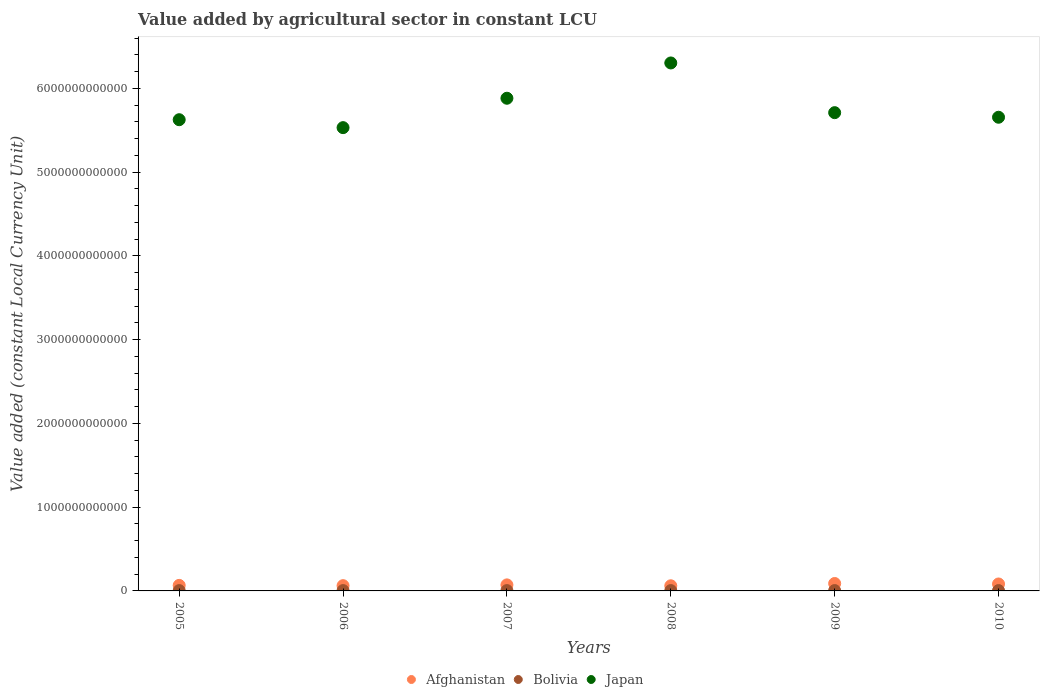How many different coloured dotlines are there?
Provide a succinct answer. 3. Is the number of dotlines equal to the number of legend labels?
Provide a short and direct response. Yes. What is the value added by agricultural sector in Afghanistan in 2006?
Give a very brief answer. 6.28e+1. Across all years, what is the maximum value added by agricultural sector in Bolivia?
Make the answer very short. 4.17e+09. Across all years, what is the minimum value added by agricultural sector in Afghanistan?
Ensure brevity in your answer.  6.13e+1. In which year was the value added by agricultural sector in Bolivia maximum?
Keep it short and to the point. 2009. In which year was the value added by agricultural sector in Bolivia minimum?
Ensure brevity in your answer.  2005. What is the total value added by agricultural sector in Afghanistan in the graph?
Ensure brevity in your answer.  4.34e+11. What is the difference between the value added by agricultural sector in Bolivia in 2008 and that in 2010?
Your response must be concise. -9.90e+07. What is the difference between the value added by agricultural sector in Bolivia in 2008 and the value added by agricultural sector in Japan in 2007?
Give a very brief answer. -5.88e+12. What is the average value added by agricultural sector in Afghanistan per year?
Your answer should be compact. 7.23e+1. In the year 2009, what is the difference between the value added by agricultural sector in Bolivia and value added by agricultural sector in Japan?
Provide a succinct answer. -5.71e+12. What is the ratio of the value added by agricultural sector in Afghanistan in 2007 to that in 2010?
Ensure brevity in your answer.  0.87. Is the difference between the value added by agricultural sector in Bolivia in 2006 and 2010 greater than the difference between the value added by agricultural sector in Japan in 2006 and 2010?
Ensure brevity in your answer.  Yes. What is the difference between the highest and the second highest value added by agricultural sector in Bolivia?
Ensure brevity in your answer.  4.91e+07. What is the difference between the highest and the lowest value added by agricultural sector in Japan?
Offer a very short reply. 7.72e+11. In how many years, is the value added by agricultural sector in Bolivia greater than the average value added by agricultural sector in Bolivia taken over all years?
Your answer should be very brief. 3. Is it the case that in every year, the sum of the value added by agricultural sector in Bolivia and value added by agricultural sector in Afghanistan  is greater than the value added by agricultural sector in Japan?
Offer a very short reply. No. What is the difference between two consecutive major ticks on the Y-axis?
Offer a very short reply. 1.00e+12. Are the values on the major ticks of Y-axis written in scientific E-notation?
Give a very brief answer. No. Does the graph contain grids?
Your answer should be very brief. No. What is the title of the graph?
Provide a short and direct response. Value added by agricultural sector in constant LCU. Does "Arab World" appear as one of the legend labels in the graph?
Provide a succinct answer. No. What is the label or title of the X-axis?
Offer a terse response. Years. What is the label or title of the Y-axis?
Ensure brevity in your answer.  Value added (constant Local Currency Unit). What is the Value added (constant Local Currency Unit) in Afghanistan in 2005?
Provide a short and direct response. 6.62e+1. What is the Value added (constant Local Currency Unit) in Bolivia in 2005?
Your answer should be very brief. 3.78e+09. What is the Value added (constant Local Currency Unit) in Japan in 2005?
Offer a very short reply. 5.63e+12. What is the Value added (constant Local Currency Unit) of Afghanistan in 2006?
Make the answer very short. 6.28e+1. What is the Value added (constant Local Currency Unit) in Bolivia in 2006?
Give a very brief answer. 3.94e+09. What is the Value added (constant Local Currency Unit) of Japan in 2006?
Offer a terse response. 5.53e+12. What is the Value added (constant Local Currency Unit) of Afghanistan in 2007?
Make the answer very short. 7.21e+1. What is the Value added (constant Local Currency Unit) of Bolivia in 2007?
Make the answer very short. 3.92e+09. What is the Value added (constant Local Currency Unit) of Japan in 2007?
Make the answer very short. 5.88e+12. What is the Value added (constant Local Currency Unit) in Afghanistan in 2008?
Give a very brief answer. 6.13e+1. What is the Value added (constant Local Currency Unit) of Bolivia in 2008?
Make the answer very short. 4.02e+09. What is the Value added (constant Local Currency Unit) in Japan in 2008?
Keep it short and to the point. 6.30e+12. What is the Value added (constant Local Currency Unit) in Afghanistan in 2009?
Offer a very short reply. 8.86e+1. What is the Value added (constant Local Currency Unit) of Bolivia in 2009?
Ensure brevity in your answer.  4.17e+09. What is the Value added (constant Local Currency Unit) of Japan in 2009?
Provide a short and direct response. 5.71e+12. What is the Value added (constant Local Currency Unit) in Afghanistan in 2010?
Ensure brevity in your answer.  8.30e+1. What is the Value added (constant Local Currency Unit) in Bolivia in 2010?
Provide a short and direct response. 4.12e+09. What is the Value added (constant Local Currency Unit) in Japan in 2010?
Your answer should be very brief. 5.66e+12. Across all years, what is the maximum Value added (constant Local Currency Unit) in Afghanistan?
Offer a very short reply. 8.86e+1. Across all years, what is the maximum Value added (constant Local Currency Unit) of Bolivia?
Offer a very short reply. 4.17e+09. Across all years, what is the maximum Value added (constant Local Currency Unit) of Japan?
Offer a very short reply. 6.30e+12. Across all years, what is the minimum Value added (constant Local Currency Unit) of Afghanistan?
Provide a succinct answer. 6.13e+1. Across all years, what is the minimum Value added (constant Local Currency Unit) in Bolivia?
Offer a terse response. 3.78e+09. Across all years, what is the minimum Value added (constant Local Currency Unit) of Japan?
Provide a short and direct response. 5.53e+12. What is the total Value added (constant Local Currency Unit) of Afghanistan in the graph?
Offer a terse response. 4.34e+11. What is the total Value added (constant Local Currency Unit) of Bolivia in the graph?
Provide a succinct answer. 2.40e+1. What is the total Value added (constant Local Currency Unit) of Japan in the graph?
Make the answer very short. 3.47e+13. What is the difference between the Value added (constant Local Currency Unit) of Afghanistan in 2005 and that in 2006?
Provide a succinct answer. 3.38e+09. What is the difference between the Value added (constant Local Currency Unit) in Bolivia in 2005 and that in 2006?
Make the answer very short. -1.61e+08. What is the difference between the Value added (constant Local Currency Unit) in Japan in 2005 and that in 2006?
Give a very brief answer. 9.47e+1. What is the difference between the Value added (constant Local Currency Unit) in Afghanistan in 2005 and that in 2007?
Make the answer very short. -5.85e+09. What is the difference between the Value added (constant Local Currency Unit) of Bolivia in 2005 and that in 2007?
Your answer should be compact. -1.41e+08. What is the difference between the Value added (constant Local Currency Unit) in Japan in 2005 and that in 2007?
Make the answer very short. -2.56e+11. What is the difference between the Value added (constant Local Currency Unit) of Afghanistan in 2005 and that in 2008?
Your response must be concise. 4.90e+09. What is the difference between the Value added (constant Local Currency Unit) in Bolivia in 2005 and that in 2008?
Keep it short and to the point. -2.44e+08. What is the difference between the Value added (constant Local Currency Unit) of Japan in 2005 and that in 2008?
Offer a terse response. -6.78e+11. What is the difference between the Value added (constant Local Currency Unit) in Afghanistan in 2005 and that in 2009?
Provide a succinct answer. -2.24e+1. What is the difference between the Value added (constant Local Currency Unit) of Bolivia in 2005 and that in 2009?
Give a very brief answer. -3.92e+08. What is the difference between the Value added (constant Local Currency Unit) in Japan in 2005 and that in 2009?
Offer a very short reply. -8.42e+1. What is the difference between the Value added (constant Local Currency Unit) of Afghanistan in 2005 and that in 2010?
Your response must be concise. -1.68e+1. What is the difference between the Value added (constant Local Currency Unit) of Bolivia in 2005 and that in 2010?
Provide a short and direct response. -3.43e+08. What is the difference between the Value added (constant Local Currency Unit) in Japan in 2005 and that in 2010?
Provide a succinct answer. -2.94e+1. What is the difference between the Value added (constant Local Currency Unit) in Afghanistan in 2006 and that in 2007?
Offer a very short reply. -9.23e+09. What is the difference between the Value added (constant Local Currency Unit) of Bolivia in 2006 and that in 2007?
Your answer should be compact. 1.99e+07. What is the difference between the Value added (constant Local Currency Unit) of Japan in 2006 and that in 2007?
Your response must be concise. -3.51e+11. What is the difference between the Value added (constant Local Currency Unit) in Afghanistan in 2006 and that in 2008?
Your answer should be compact. 1.52e+09. What is the difference between the Value added (constant Local Currency Unit) in Bolivia in 2006 and that in 2008?
Ensure brevity in your answer.  -8.26e+07. What is the difference between the Value added (constant Local Currency Unit) of Japan in 2006 and that in 2008?
Your answer should be very brief. -7.72e+11. What is the difference between the Value added (constant Local Currency Unit) in Afghanistan in 2006 and that in 2009?
Make the answer very short. -2.58e+1. What is the difference between the Value added (constant Local Currency Unit) of Bolivia in 2006 and that in 2009?
Give a very brief answer. -2.31e+08. What is the difference between the Value added (constant Local Currency Unit) of Japan in 2006 and that in 2009?
Your response must be concise. -1.79e+11. What is the difference between the Value added (constant Local Currency Unit) in Afghanistan in 2006 and that in 2010?
Provide a short and direct response. -2.02e+1. What is the difference between the Value added (constant Local Currency Unit) in Bolivia in 2006 and that in 2010?
Your answer should be very brief. -1.82e+08. What is the difference between the Value added (constant Local Currency Unit) in Japan in 2006 and that in 2010?
Ensure brevity in your answer.  -1.24e+11. What is the difference between the Value added (constant Local Currency Unit) in Afghanistan in 2007 and that in 2008?
Your answer should be compact. 1.07e+1. What is the difference between the Value added (constant Local Currency Unit) of Bolivia in 2007 and that in 2008?
Your response must be concise. -1.03e+08. What is the difference between the Value added (constant Local Currency Unit) of Japan in 2007 and that in 2008?
Provide a succinct answer. -4.21e+11. What is the difference between the Value added (constant Local Currency Unit) in Afghanistan in 2007 and that in 2009?
Make the answer very short. -1.66e+1. What is the difference between the Value added (constant Local Currency Unit) in Bolivia in 2007 and that in 2009?
Ensure brevity in your answer.  -2.51e+08. What is the difference between the Value added (constant Local Currency Unit) in Japan in 2007 and that in 2009?
Your response must be concise. 1.72e+11. What is the difference between the Value added (constant Local Currency Unit) of Afghanistan in 2007 and that in 2010?
Your response must be concise. -1.09e+1. What is the difference between the Value added (constant Local Currency Unit) in Bolivia in 2007 and that in 2010?
Offer a very short reply. -2.01e+08. What is the difference between the Value added (constant Local Currency Unit) of Japan in 2007 and that in 2010?
Provide a succinct answer. 2.27e+11. What is the difference between the Value added (constant Local Currency Unit) of Afghanistan in 2008 and that in 2009?
Ensure brevity in your answer.  -2.73e+1. What is the difference between the Value added (constant Local Currency Unit) in Bolivia in 2008 and that in 2009?
Provide a succinct answer. -1.48e+08. What is the difference between the Value added (constant Local Currency Unit) of Japan in 2008 and that in 2009?
Offer a very short reply. 5.93e+11. What is the difference between the Value added (constant Local Currency Unit) of Afghanistan in 2008 and that in 2010?
Keep it short and to the point. -2.17e+1. What is the difference between the Value added (constant Local Currency Unit) of Bolivia in 2008 and that in 2010?
Provide a short and direct response. -9.90e+07. What is the difference between the Value added (constant Local Currency Unit) in Japan in 2008 and that in 2010?
Offer a very short reply. 6.48e+11. What is the difference between the Value added (constant Local Currency Unit) in Afghanistan in 2009 and that in 2010?
Make the answer very short. 5.65e+09. What is the difference between the Value added (constant Local Currency Unit) in Bolivia in 2009 and that in 2010?
Provide a short and direct response. 4.91e+07. What is the difference between the Value added (constant Local Currency Unit) of Japan in 2009 and that in 2010?
Keep it short and to the point. 5.48e+1. What is the difference between the Value added (constant Local Currency Unit) of Afghanistan in 2005 and the Value added (constant Local Currency Unit) of Bolivia in 2006?
Ensure brevity in your answer.  6.23e+1. What is the difference between the Value added (constant Local Currency Unit) in Afghanistan in 2005 and the Value added (constant Local Currency Unit) in Japan in 2006?
Offer a terse response. -5.47e+12. What is the difference between the Value added (constant Local Currency Unit) in Bolivia in 2005 and the Value added (constant Local Currency Unit) in Japan in 2006?
Your response must be concise. -5.53e+12. What is the difference between the Value added (constant Local Currency Unit) of Afghanistan in 2005 and the Value added (constant Local Currency Unit) of Bolivia in 2007?
Provide a succinct answer. 6.23e+1. What is the difference between the Value added (constant Local Currency Unit) in Afghanistan in 2005 and the Value added (constant Local Currency Unit) in Japan in 2007?
Ensure brevity in your answer.  -5.82e+12. What is the difference between the Value added (constant Local Currency Unit) in Bolivia in 2005 and the Value added (constant Local Currency Unit) in Japan in 2007?
Provide a short and direct response. -5.88e+12. What is the difference between the Value added (constant Local Currency Unit) in Afghanistan in 2005 and the Value added (constant Local Currency Unit) in Bolivia in 2008?
Your answer should be compact. 6.22e+1. What is the difference between the Value added (constant Local Currency Unit) of Afghanistan in 2005 and the Value added (constant Local Currency Unit) of Japan in 2008?
Your response must be concise. -6.24e+12. What is the difference between the Value added (constant Local Currency Unit) of Bolivia in 2005 and the Value added (constant Local Currency Unit) of Japan in 2008?
Your response must be concise. -6.30e+12. What is the difference between the Value added (constant Local Currency Unit) of Afghanistan in 2005 and the Value added (constant Local Currency Unit) of Bolivia in 2009?
Offer a terse response. 6.20e+1. What is the difference between the Value added (constant Local Currency Unit) in Afghanistan in 2005 and the Value added (constant Local Currency Unit) in Japan in 2009?
Make the answer very short. -5.64e+12. What is the difference between the Value added (constant Local Currency Unit) in Bolivia in 2005 and the Value added (constant Local Currency Unit) in Japan in 2009?
Your answer should be compact. -5.71e+12. What is the difference between the Value added (constant Local Currency Unit) in Afghanistan in 2005 and the Value added (constant Local Currency Unit) in Bolivia in 2010?
Your answer should be very brief. 6.21e+1. What is the difference between the Value added (constant Local Currency Unit) in Afghanistan in 2005 and the Value added (constant Local Currency Unit) in Japan in 2010?
Offer a terse response. -5.59e+12. What is the difference between the Value added (constant Local Currency Unit) in Bolivia in 2005 and the Value added (constant Local Currency Unit) in Japan in 2010?
Provide a short and direct response. -5.65e+12. What is the difference between the Value added (constant Local Currency Unit) in Afghanistan in 2006 and the Value added (constant Local Currency Unit) in Bolivia in 2007?
Make the answer very short. 5.89e+1. What is the difference between the Value added (constant Local Currency Unit) in Afghanistan in 2006 and the Value added (constant Local Currency Unit) in Japan in 2007?
Provide a succinct answer. -5.82e+12. What is the difference between the Value added (constant Local Currency Unit) of Bolivia in 2006 and the Value added (constant Local Currency Unit) of Japan in 2007?
Provide a short and direct response. -5.88e+12. What is the difference between the Value added (constant Local Currency Unit) in Afghanistan in 2006 and the Value added (constant Local Currency Unit) in Bolivia in 2008?
Make the answer very short. 5.88e+1. What is the difference between the Value added (constant Local Currency Unit) in Afghanistan in 2006 and the Value added (constant Local Currency Unit) in Japan in 2008?
Keep it short and to the point. -6.24e+12. What is the difference between the Value added (constant Local Currency Unit) of Bolivia in 2006 and the Value added (constant Local Currency Unit) of Japan in 2008?
Your answer should be very brief. -6.30e+12. What is the difference between the Value added (constant Local Currency Unit) of Afghanistan in 2006 and the Value added (constant Local Currency Unit) of Bolivia in 2009?
Offer a very short reply. 5.87e+1. What is the difference between the Value added (constant Local Currency Unit) in Afghanistan in 2006 and the Value added (constant Local Currency Unit) in Japan in 2009?
Provide a short and direct response. -5.65e+12. What is the difference between the Value added (constant Local Currency Unit) of Bolivia in 2006 and the Value added (constant Local Currency Unit) of Japan in 2009?
Your answer should be compact. -5.71e+12. What is the difference between the Value added (constant Local Currency Unit) in Afghanistan in 2006 and the Value added (constant Local Currency Unit) in Bolivia in 2010?
Provide a succinct answer. 5.87e+1. What is the difference between the Value added (constant Local Currency Unit) in Afghanistan in 2006 and the Value added (constant Local Currency Unit) in Japan in 2010?
Your answer should be very brief. -5.59e+12. What is the difference between the Value added (constant Local Currency Unit) in Bolivia in 2006 and the Value added (constant Local Currency Unit) in Japan in 2010?
Give a very brief answer. -5.65e+12. What is the difference between the Value added (constant Local Currency Unit) in Afghanistan in 2007 and the Value added (constant Local Currency Unit) in Bolivia in 2008?
Ensure brevity in your answer.  6.80e+1. What is the difference between the Value added (constant Local Currency Unit) of Afghanistan in 2007 and the Value added (constant Local Currency Unit) of Japan in 2008?
Ensure brevity in your answer.  -6.23e+12. What is the difference between the Value added (constant Local Currency Unit) of Bolivia in 2007 and the Value added (constant Local Currency Unit) of Japan in 2008?
Your answer should be compact. -6.30e+12. What is the difference between the Value added (constant Local Currency Unit) in Afghanistan in 2007 and the Value added (constant Local Currency Unit) in Bolivia in 2009?
Make the answer very short. 6.79e+1. What is the difference between the Value added (constant Local Currency Unit) of Afghanistan in 2007 and the Value added (constant Local Currency Unit) of Japan in 2009?
Provide a succinct answer. -5.64e+12. What is the difference between the Value added (constant Local Currency Unit) in Bolivia in 2007 and the Value added (constant Local Currency Unit) in Japan in 2009?
Provide a short and direct response. -5.71e+12. What is the difference between the Value added (constant Local Currency Unit) in Afghanistan in 2007 and the Value added (constant Local Currency Unit) in Bolivia in 2010?
Offer a very short reply. 6.79e+1. What is the difference between the Value added (constant Local Currency Unit) of Afghanistan in 2007 and the Value added (constant Local Currency Unit) of Japan in 2010?
Your answer should be very brief. -5.58e+12. What is the difference between the Value added (constant Local Currency Unit) of Bolivia in 2007 and the Value added (constant Local Currency Unit) of Japan in 2010?
Your response must be concise. -5.65e+12. What is the difference between the Value added (constant Local Currency Unit) of Afghanistan in 2008 and the Value added (constant Local Currency Unit) of Bolivia in 2009?
Your answer should be compact. 5.71e+1. What is the difference between the Value added (constant Local Currency Unit) in Afghanistan in 2008 and the Value added (constant Local Currency Unit) in Japan in 2009?
Your answer should be compact. -5.65e+12. What is the difference between the Value added (constant Local Currency Unit) in Bolivia in 2008 and the Value added (constant Local Currency Unit) in Japan in 2009?
Your answer should be very brief. -5.71e+12. What is the difference between the Value added (constant Local Currency Unit) of Afghanistan in 2008 and the Value added (constant Local Currency Unit) of Bolivia in 2010?
Provide a short and direct response. 5.72e+1. What is the difference between the Value added (constant Local Currency Unit) in Afghanistan in 2008 and the Value added (constant Local Currency Unit) in Japan in 2010?
Provide a succinct answer. -5.59e+12. What is the difference between the Value added (constant Local Currency Unit) of Bolivia in 2008 and the Value added (constant Local Currency Unit) of Japan in 2010?
Make the answer very short. -5.65e+12. What is the difference between the Value added (constant Local Currency Unit) in Afghanistan in 2009 and the Value added (constant Local Currency Unit) in Bolivia in 2010?
Ensure brevity in your answer.  8.45e+1. What is the difference between the Value added (constant Local Currency Unit) in Afghanistan in 2009 and the Value added (constant Local Currency Unit) in Japan in 2010?
Your response must be concise. -5.57e+12. What is the difference between the Value added (constant Local Currency Unit) of Bolivia in 2009 and the Value added (constant Local Currency Unit) of Japan in 2010?
Offer a very short reply. -5.65e+12. What is the average Value added (constant Local Currency Unit) in Afghanistan per year?
Offer a very short reply. 7.23e+1. What is the average Value added (constant Local Currency Unit) in Bolivia per year?
Offer a very short reply. 3.99e+09. What is the average Value added (constant Local Currency Unit) in Japan per year?
Your answer should be compact. 5.79e+12. In the year 2005, what is the difference between the Value added (constant Local Currency Unit) in Afghanistan and Value added (constant Local Currency Unit) in Bolivia?
Offer a very short reply. 6.24e+1. In the year 2005, what is the difference between the Value added (constant Local Currency Unit) of Afghanistan and Value added (constant Local Currency Unit) of Japan?
Ensure brevity in your answer.  -5.56e+12. In the year 2005, what is the difference between the Value added (constant Local Currency Unit) of Bolivia and Value added (constant Local Currency Unit) of Japan?
Give a very brief answer. -5.62e+12. In the year 2006, what is the difference between the Value added (constant Local Currency Unit) in Afghanistan and Value added (constant Local Currency Unit) in Bolivia?
Make the answer very short. 5.89e+1. In the year 2006, what is the difference between the Value added (constant Local Currency Unit) of Afghanistan and Value added (constant Local Currency Unit) of Japan?
Offer a very short reply. -5.47e+12. In the year 2006, what is the difference between the Value added (constant Local Currency Unit) of Bolivia and Value added (constant Local Currency Unit) of Japan?
Offer a very short reply. -5.53e+12. In the year 2007, what is the difference between the Value added (constant Local Currency Unit) of Afghanistan and Value added (constant Local Currency Unit) of Bolivia?
Provide a succinct answer. 6.81e+1. In the year 2007, what is the difference between the Value added (constant Local Currency Unit) of Afghanistan and Value added (constant Local Currency Unit) of Japan?
Offer a very short reply. -5.81e+12. In the year 2007, what is the difference between the Value added (constant Local Currency Unit) in Bolivia and Value added (constant Local Currency Unit) in Japan?
Offer a very short reply. -5.88e+12. In the year 2008, what is the difference between the Value added (constant Local Currency Unit) of Afghanistan and Value added (constant Local Currency Unit) of Bolivia?
Provide a short and direct response. 5.73e+1. In the year 2008, what is the difference between the Value added (constant Local Currency Unit) of Afghanistan and Value added (constant Local Currency Unit) of Japan?
Provide a succinct answer. -6.24e+12. In the year 2008, what is the difference between the Value added (constant Local Currency Unit) of Bolivia and Value added (constant Local Currency Unit) of Japan?
Offer a very short reply. -6.30e+12. In the year 2009, what is the difference between the Value added (constant Local Currency Unit) of Afghanistan and Value added (constant Local Currency Unit) of Bolivia?
Your response must be concise. 8.45e+1. In the year 2009, what is the difference between the Value added (constant Local Currency Unit) in Afghanistan and Value added (constant Local Currency Unit) in Japan?
Keep it short and to the point. -5.62e+12. In the year 2009, what is the difference between the Value added (constant Local Currency Unit) of Bolivia and Value added (constant Local Currency Unit) of Japan?
Keep it short and to the point. -5.71e+12. In the year 2010, what is the difference between the Value added (constant Local Currency Unit) of Afghanistan and Value added (constant Local Currency Unit) of Bolivia?
Your answer should be very brief. 7.89e+1. In the year 2010, what is the difference between the Value added (constant Local Currency Unit) of Afghanistan and Value added (constant Local Currency Unit) of Japan?
Your answer should be very brief. -5.57e+12. In the year 2010, what is the difference between the Value added (constant Local Currency Unit) of Bolivia and Value added (constant Local Currency Unit) of Japan?
Provide a short and direct response. -5.65e+12. What is the ratio of the Value added (constant Local Currency Unit) in Afghanistan in 2005 to that in 2006?
Make the answer very short. 1.05. What is the ratio of the Value added (constant Local Currency Unit) of Bolivia in 2005 to that in 2006?
Ensure brevity in your answer.  0.96. What is the ratio of the Value added (constant Local Currency Unit) in Japan in 2005 to that in 2006?
Offer a terse response. 1.02. What is the ratio of the Value added (constant Local Currency Unit) of Afghanistan in 2005 to that in 2007?
Your answer should be very brief. 0.92. What is the ratio of the Value added (constant Local Currency Unit) of Bolivia in 2005 to that in 2007?
Offer a terse response. 0.96. What is the ratio of the Value added (constant Local Currency Unit) in Japan in 2005 to that in 2007?
Keep it short and to the point. 0.96. What is the ratio of the Value added (constant Local Currency Unit) in Afghanistan in 2005 to that in 2008?
Ensure brevity in your answer.  1.08. What is the ratio of the Value added (constant Local Currency Unit) of Bolivia in 2005 to that in 2008?
Your response must be concise. 0.94. What is the ratio of the Value added (constant Local Currency Unit) in Japan in 2005 to that in 2008?
Give a very brief answer. 0.89. What is the ratio of the Value added (constant Local Currency Unit) of Afghanistan in 2005 to that in 2009?
Give a very brief answer. 0.75. What is the ratio of the Value added (constant Local Currency Unit) of Bolivia in 2005 to that in 2009?
Your answer should be compact. 0.91. What is the ratio of the Value added (constant Local Currency Unit) in Japan in 2005 to that in 2009?
Offer a terse response. 0.99. What is the ratio of the Value added (constant Local Currency Unit) of Afghanistan in 2005 to that in 2010?
Provide a succinct answer. 0.8. What is the ratio of the Value added (constant Local Currency Unit) in Bolivia in 2005 to that in 2010?
Your answer should be very brief. 0.92. What is the ratio of the Value added (constant Local Currency Unit) of Afghanistan in 2006 to that in 2007?
Provide a short and direct response. 0.87. What is the ratio of the Value added (constant Local Currency Unit) of Japan in 2006 to that in 2007?
Provide a succinct answer. 0.94. What is the ratio of the Value added (constant Local Currency Unit) of Afghanistan in 2006 to that in 2008?
Your answer should be very brief. 1.02. What is the ratio of the Value added (constant Local Currency Unit) of Bolivia in 2006 to that in 2008?
Offer a very short reply. 0.98. What is the ratio of the Value added (constant Local Currency Unit) in Japan in 2006 to that in 2008?
Provide a succinct answer. 0.88. What is the ratio of the Value added (constant Local Currency Unit) in Afghanistan in 2006 to that in 2009?
Your answer should be very brief. 0.71. What is the ratio of the Value added (constant Local Currency Unit) of Bolivia in 2006 to that in 2009?
Provide a succinct answer. 0.94. What is the ratio of the Value added (constant Local Currency Unit) of Japan in 2006 to that in 2009?
Keep it short and to the point. 0.97. What is the ratio of the Value added (constant Local Currency Unit) in Afghanistan in 2006 to that in 2010?
Offer a terse response. 0.76. What is the ratio of the Value added (constant Local Currency Unit) of Bolivia in 2006 to that in 2010?
Offer a very short reply. 0.96. What is the ratio of the Value added (constant Local Currency Unit) in Japan in 2006 to that in 2010?
Provide a short and direct response. 0.98. What is the ratio of the Value added (constant Local Currency Unit) in Afghanistan in 2007 to that in 2008?
Make the answer very short. 1.18. What is the ratio of the Value added (constant Local Currency Unit) in Bolivia in 2007 to that in 2008?
Keep it short and to the point. 0.97. What is the ratio of the Value added (constant Local Currency Unit) in Japan in 2007 to that in 2008?
Give a very brief answer. 0.93. What is the ratio of the Value added (constant Local Currency Unit) in Afghanistan in 2007 to that in 2009?
Your response must be concise. 0.81. What is the ratio of the Value added (constant Local Currency Unit) in Bolivia in 2007 to that in 2009?
Offer a terse response. 0.94. What is the ratio of the Value added (constant Local Currency Unit) of Japan in 2007 to that in 2009?
Give a very brief answer. 1.03. What is the ratio of the Value added (constant Local Currency Unit) in Afghanistan in 2007 to that in 2010?
Make the answer very short. 0.87. What is the ratio of the Value added (constant Local Currency Unit) in Bolivia in 2007 to that in 2010?
Ensure brevity in your answer.  0.95. What is the ratio of the Value added (constant Local Currency Unit) of Japan in 2007 to that in 2010?
Ensure brevity in your answer.  1.04. What is the ratio of the Value added (constant Local Currency Unit) of Afghanistan in 2008 to that in 2009?
Keep it short and to the point. 0.69. What is the ratio of the Value added (constant Local Currency Unit) in Bolivia in 2008 to that in 2009?
Offer a very short reply. 0.96. What is the ratio of the Value added (constant Local Currency Unit) of Japan in 2008 to that in 2009?
Keep it short and to the point. 1.1. What is the ratio of the Value added (constant Local Currency Unit) of Afghanistan in 2008 to that in 2010?
Keep it short and to the point. 0.74. What is the ratio of the Value added (constant Local Currency Unit) of Japan in 2008 to that in 2010?
Ensure brevity in your answer.  1.11. What is the ratio of the Value added (constant Local Currency Unit) of Afghanistan in 2009 to that in 2010?
Ensure brevity in your answer.  1.07. What is the ratio of the Value added (constant Local Currency Unit) of Bolivia in 2009 to that in 2010?
Ensure brevity in your answer.  1.01. What is the ratio of the Value added (constant Local Currency Unit) in Japan in 2009 to that in 2010?
Offer a terse response. 1.01. What is the difference between the highest and the second highest Value added (constant Local Currency Unit) of Afghanistan?
Ensure brevity in your answer.  5.65e+09. What is the difference between the highest and the second highest Value added (constant Local Currency Unit) of Bolivia?
Keep it short and to the point. 4.91e+07. What is the difference between the highest and the second highest Value added (constant Local Currency Unit) in Japan?
Offer a terse response. 4.21e+11. What is the difference between the highest and the lowest Value added (constant Local Currency Unit) in Afghanistan?
Ensure brevity in your answer.  2.73e+1. What is the difference between the highest and the lowest Value added (constant Local Currency Unit) of Bolivia?
Ensure brevity in your answer.  3.92e+08. What is the difference between the highest and the lowest Value added (constant Local Currency Unit) of Japan?
Keep it short and to the point. 7.72e+11. 